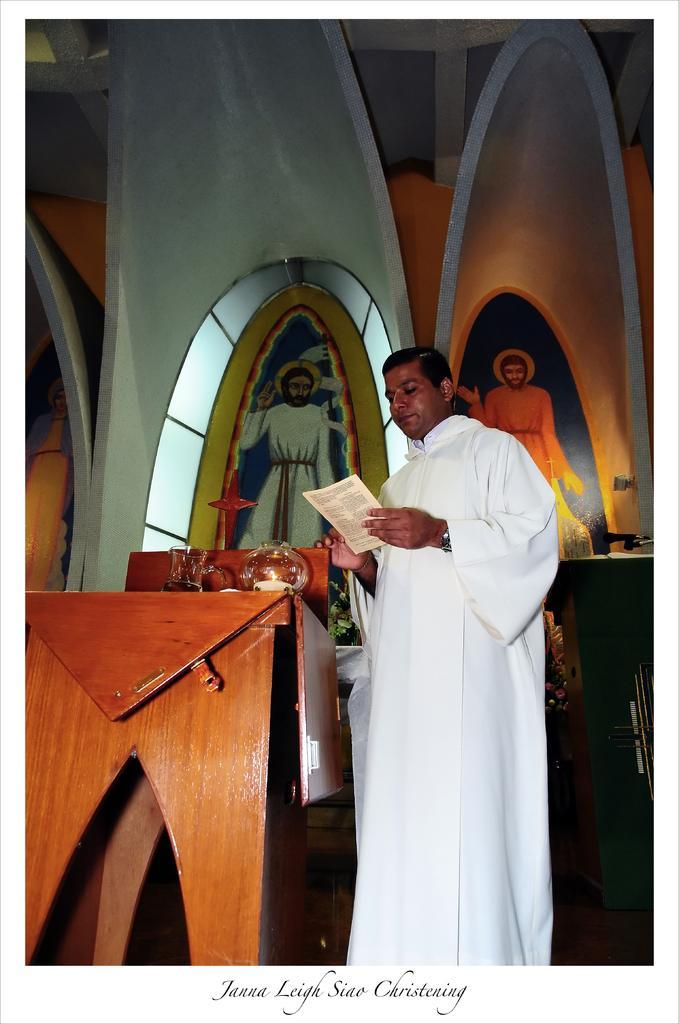How would you summarize this image in a sentence or two? In this image we can see a man wearing white color dress holding some paper in his hands, standing behind wooden podium, on right side of the image we can see another podium on which there is microphone and in the background of the image there is a wall and some paintings are attached to the wall. 